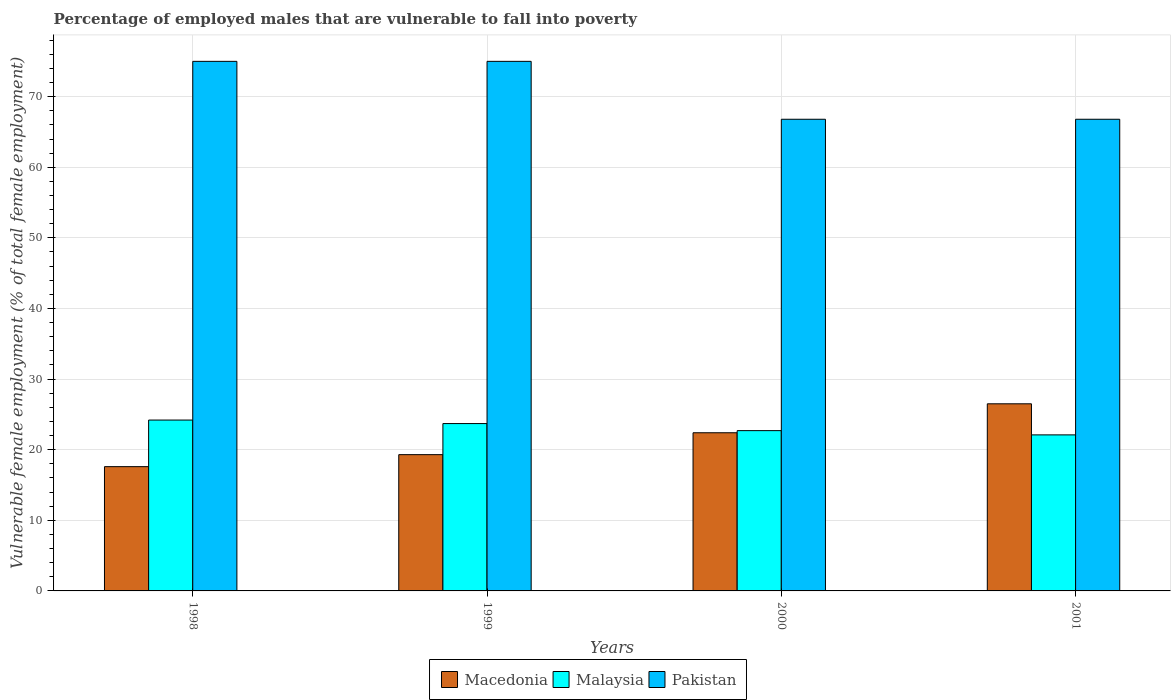What is the label of the 1st group of bars from the left?
Offer a very short reply. 1998. What is the percentage of employed males who are vulnerable to fall into poverty in Macedonia in 2000?
Keep it short and to the point. 22.4. Across all years, what is the maximum percentage of employed males who are vulnerable to fall into poverty in Malaysia?
Your answer should be compact. 24.2. Across all years, what is the minimum percentage of employed males who are vulnerable to fall into poverty in Malaysia?
Give a very brief answer. 22.1. In which year was the percentage of employed males who are vulnerable to fall into poverty in Macedonia maximum?
Your response must be concise. 2001. What is the total percentage of employed males who are vulnerable to fall into poverty in Macedonia in the graph?
Ensure brevity in your answer.  85.8. What is the difference between the percentage of employed males who are vulnerable to fall into poverty in Malaysia in 1998 and that in 2000?
Offer a terse response. 1.5. What is the difference between the percentage of employed males who are vulnerable to fall into poverty in Macedonia in 2000 and the percentage of employed males who are vulnerable to fall into poverty in Malaysia in 1998?
Your answer should be compact. -1.8. What is the average percentage of employed males who are vulnerable to fall into poverty in Macedonia per year?
Offer a terse response. 21.45. In the year 2000, what is the difference between the percentage of employed males who are vulnerable to fall into poverty in Malaysia and percentage of employed males who are vulnerable to fall into poverty in Macedonia?
Your response must be concise. 0.3. In how many years, is the percentage of employed males who are vulnerable to fall into poverty in Malaysia greater than 74 %?
Ensure brevity in your answer.  0. What is the ratio of the percentage of employed males who are vulnerable to fall into poverty in Macedonia in 1998 to that in 1999?
Keep it short and to the point. 0.91. What is the difference between the highest and the lowest percentage of employed males who are vulnerable to fall into poverty in Pakistan?
Your answer should be compact. 8.2. In how many years, is the percentage of employed males who are vulnerable to fall into poverty in Pakistan greater than the average percentage of employed males who are vulnerable to fall into poverty in Pakistan taken over all years?
Your answer should be compact. 2. Is the sum of the percentage of employed males who are vulnerable to fall into poverty in Macedonia in 1999 and 2000 greater than the maximum percentage of employed males who are vulnerable to fall into poverty in Pakistan across all years?
Provide a succinct answer. No. What does the 1st bar from the left in 1998 represents?
Your response must be concise. Macedonia. What does the 3rd bar from the right in 2000 represents?
Give a very brief answer. Macedonia. How many years are there in the graph?
Make the answer very short. 4. Are the values on the major ticks of Y-axis written in scientific E-notation?
Your response must be concise. No. Where does the legend appear in the graph?
Offer a terse response. Bottom center. How many legend labels are there?
Provide a succinct answer. 3. What is the title of the graph?
Your answer should be compact. Percentage of employed males that are vulnerable to fall into poverty. What is the label or title of the Y-axis?
Provide a short and direct response. Vulnerable female employment (% of total female employment). What is the Vulnerable female employment (% of total female employment) in Macedonia in 1998?
Offer a terse response. 17.6. What is the Vulnerable female employment (% of total female employment) in Malaysia in 1998?
Give a very brief answer. 24.2. What is the Vulnerable female employment (% of total female employment) in Macedonia in 1999?
Your answer should be very brief. 19.3. What is the Vulnerable female employment (% of total female employment) in Malaysia in 1999?
Ensure brevity in your answer.  23.7. What is the Vulnerable female employment (% of total female employment) in Pakistan in 1999?
Your response must be concise. 75. What is the Vulnerable female employment (% of total female employment) of Macedonia in 2000?
Give a very brief answer. 22.4. What is the Vulnerable female employment (% of total female employment) of Malaysia in 2000?
Offer a very short reply. 22.7. What is the Vulnerable female employment (% of total female employment) of Pakistan in 2000?
Offer a terse response. 66.8. What is the Vulnerable female employment (% of total female employment) in Macedonia in 2001?
Your answer should be very brief. 26.5. What is the Vulnerable female employment (% of total female employment) of Malaysia in 2001?
Provide a succinct answer. 22.1. What is the Vulnerable female employment (% of total female employment) of Pakistan in 2001?
Your answer should be compact. 66.8. Across all years, what is the maximum Vulnerable female employment (% of total female employment) in Macedonia?
Offer a very short reply. 26.5. Across all years, what is the maximum Vulnerable female employment (% of total female employment) in Malaysia?
Your answer should be very brief. 24.2. Across all years, what is the minimum Vulnerable female employment (% of total female employment) of Macedonia?
Keep it short and to the point. 17.6. Across all years, what is the minimum Vulnerable female employment (% of total female employment) in Malaysia?
Give a very brief answer. 22.1. Across all years, what is the minimum Vulnerable female employment (% of total female employment) of Pakistan?
Your answer should be very brief. 66.8. What is the total Vulnerable female employment (% of total female employment) of Macedonia in the graph?
Provide a short and direct response. 85.8. What is the total Vulnerable female employment (% of total female employment) in Malaysia in the graph?
Keep it short and to the point. 92.7. What is the total Vulnerable female employment (% of total female employment) in Pakistan in the graph?
Provide a succinct answer. 283.6. What is the difference between the Vulnerable female employment (% of total female employment) in Malaysia in 1998 and that in 2000?
Provide a short and direct response. 1.5. What is the difference between the Vulnerable female employment (% of total female employment) in Macedonia in 1998 and that in 2001?
Provide a short and direct response. -8.9. What is the difference between the Vulnerable female employment (% of total female employment) of Malaysia in 1998 and that in 2001?
Your answer should be compact. 2.1. What is the difference between the Vulnerable female employment (% of total female employment) in Pakistan in 1998 and that in 2001?
Offer a very short reply. 8.2. What is the difference between the Vulnerable female employment (% of total female employment) of Macedonia in 1999 and that in 2000?
Give a very brief answer. -3.1. What is the difference between the Vulnerable female employment (% of total female employment) of Pakistan in 1999 and that in 2000?
Give a very brief answer. 8.2. What is the difference between the Vulnerable female employment (% of total female employment) in Macedonia in 1999 and that in 2001?
Make the answer very short. -7.2. What is the difference between the Vulnerable female employment (% of total female employment) in Macedonia in 1998 and the Vulnerable female employment (% of total female employment) in Pakistan in 1999?
Your answer should be very brief. -57.4. What is the difference between the Vulnerable female employment (% of total female employment) in Malaysia in 1998 and the Vulnerable female employment (% of total female employment) in Pakistan in 1999?
Your response must be concise. -50.8. What is the difference between the Vulnerable female employment (% of total female employment) of Macedonia in 1998 and the Vulnerable female employment (% of total female employment) of Malaysia in 2000?
Offer a very short reply. -5.1. What is the difference between the Vulnerable female employment (% of total female employment) in Macedonia in 1998 and the Vulnerable female employment (% of total female employment) in Pakistan in 2000?
Your response must be concise. -49.2. What is the difference between the Vulnerable female employment (% of total female employment) in Malaysia in 1998 and the Vulnerable female employment (% of total female employment) in Pakistan in 2000?
Give a very brief answer. -42.6. What is the difference between the Vulnerable female employment (% of total female employment) in Macedonia in 1998 and the Vulnerable female employment (% of total female employment) in Malaysia in 2001?
Give a very brief answer. -4.5. What is the difference between the Vulnerable female employment (% of total female employment) of Macedonia in 1998 and the Vulnerable female employment (% of total female employment) of Pakistan in 2001?
Provide a succinct answer. -49.2. What is the difference between the Vulnerable female employment (% of total female employment) in Malaysia in 1998 and the Vulnerable female employment (% of total female employment) in Pakistan in 2001?
Offer a terse response. -42.6. What is the difference between the Vulnerable female employment (% of total female employment) of Macedonia in 1999 and the Vulnerable female employment (% of total female employment) of Malaysia in 2000?
Your answer should be compact. -3.4. What is the difference between the Vulnerable female employment (% of total female employment) of Macedonia in 1999 and the Vulnerable female employment (% of total female employment) of Pakistan in 2000?
Provide a short and direct response. -47.5. What is the difference between the Vulnerable female employment (% of total female employment) in Malaysia in 1999 and the Vulnerable female employment (% of total female employment) in Pakistan in 2000?
Your response must be concise. -43.1. What is the difference between the Vulnerable female employment (% of total female employment) of Macedonia in 1999 and the Vulnerable female employment (% of total female employment) of Malaysia in 2001?
Offer a terse response. -2.8. What is the difference between the Vulnerable female employment (% of total female employment) in Macedonia in 1999 and the Vulnerable female employment (% of total female employment) in Pakistan in 2001?
Give a very brief answer. -47.5. What is the difference between the Vulnerable female employment (% of total female employment) of Malaysia in 1999 and the Vulnerable female employment (% of total female employment) of Pakistan in 2001?
Make the answer very short. -43.1. What is the difference between the Vulnerable female employment (% of total female employment) of Macedonia in 2000 and the Vulnerable female employment (% of total female employment) of Malaysia in 2001?
Provide a short and direct response. 0.3. What is the difference between the Vulnerable female employment (% of total female employment) of Macedonia in 2000 and the Vulnerable female employment (% of total female employment) of Pakistan in 2001?
Offer a very short reply. -44.4. What is the difference between the Vulnerable female employment (% of total female employment) of Malaysia in 2000 and the Vulnerable female employment (% of total female employment) of Pakistan in 2001?
Your response must be concise. -44.1. What is the average Vulnerable female employment (% of total female employment) of Macedonia per year?
Make the answer very short. 21.45. What is the average Vulnerable female employment (% of total female employment) in Malaysia per year?
Provide a short and direct response. 23.18. What is the average Vulnerable female employment (% of total female employment) of Pakistan per year?
Keep it short and to the point. 70.9. In the year 1998, what is the difference between the Vulnerable female employment (% of total female employment) of Macedonia and Vulnerable female employment (% of total female employment) of Malaysia?
Your response must be concise. -6.6. In the year 1998, what is the difference between the Vulnerable female employment (% of total female employment) of Macedonia and Vulnerable female employment (% of total female employment) of Pakistan?
Give a very brief answer. -57.4. In the year 1998, what is the difference between the Vulnerable female employment (% of total female employment) in Malaysia and Vulnerable female employment (% of total female employment) in Pakistan?
Offer a terse response. -50.8. In the year 1999, what is the difference between the Vulnerable female employment (% of total female employment) in Macedonia and Vulnerable female employment (% of total female employment) in Malaysia?
Your response must be concise. -4.4. In the year 1999, what is the difference between the Vulnerable female employment (% of total female employment) in Macedonia and Vulnerable female employment (% of total female employment) in Pakistan?
Your answer should be compact. -55.7. In the year 1999, what is the difference between the Vulnerable female employment (% of total female employment) in Malaysia and Vulnerable female employment (% of total female employment) in Pakistan?
Your response must be concise. -51.3. In the year 2000, what is the difference between the Vulnerable female employment (% of total female employment) of Macedonia and Vulnerable female employment (% of total female employment) of Pakistan?
Offer a terse response. -44.4. In the year 2000, what is the difference between the Vulnerable female employment (% of total female employment) of Malaysia and Vulnerable female employment (% of total female employment) of Pakistan?
Your answer should be very brief. -44.1. In the year 2001, what is the difference between the Vulnerable female employment (% of total female employment) in Macedonia and Vulnerable female employment (% of total female employment) in Malaysia?
Your answer should be compact. 4.4. In the year 2001, what is the difference between the Vulnerable female employment (% of total female employment) of Macedonia and Vulnerable female employment (% of total female employment) of Pakistan?
Offer a terse response. -40.3. In the year 2001, what is the difference between the Vulnerable female employment (% of total female employment) of Malaysia and Vulnerable female employment (% of total female employment) of Pakistan?
Keep it short and to the point. -44.7. What is the ratio of the Vulnerable female employment (% of total female employment) of Macedonia in 1998 to that in 1999?
Your response must be concise. 0.91. What is the ratio of the Vulnerable female employment (% of total female employment) in Malaysia in 1998 to that in 1999?
Give a very brief answer. 1.02. What is the ratio of the Vulnerable female employment (% of total female employment) in Macedonia in 1998 to that in 2000?
Your response must be concise. 0.79. What is the ratio of the Vulnerable female employment (% of total female employment) of Malaysia in 1998 to that in 2000?
Your answer should be compact. 1.07. What is the ratio of the Vulnerable female employment (% of total female employment) of Pakistan in 1998 to that in 2000?
Keep it short and to the point. 1.12. What is the ratio of the Vulnerable female employment (% of total female employment) in Macedonia in 1998 to that in 2001?
Provide a short and direct response. 0.66. What is the ratio of the Vulnerable female employment (% of total female employment) of Malaysia in 1998 to that in 2001?
Ensure brevity in your answer.  1.09. What is the ratio of the Vulnerable female employment (% of total female employment) in Pakistan in 1998 to that in 2001?
Make the answer very short. 1.12. What is the ratio of the Vulnerable female employment (% of total female employment) of Macedonia in 1999 to that in 2000?
Provide a succinct answer. 0.86. What is the ratio of the Vulnerable female employment (% of total female employment) of Malaysia in 1999 to that in 2000?
Your answer should be very brief. 1.04. What is the ratio of the Vulnerable female employment (% of total female employment) of Pakistan in 1999 to that in 2000?
Your answer should be compact. 1.12. What is the ratio of the Vulnerable female employment (% of total female employment) in Macedonia in 1999 to that in 2001?
Give a very brief answer. 0.73. What is the ratio of the Vulnerable female employment (% of total female employment) of Malaysia in 1999 to that in 2001?
Keep it short and to the point. 1.07. What is the ratio of the Vulnerable female employment (% of total female employment) in Pakistan in 1999 to that in 2001?
Your answer should be compact. 1.12. What is the ratio of the Vulnerable female employment (% of total female employment) of Macedonia in 2000 to that in 2001?
Your answer should be very brief. 0.85. What is the ratio of the Vulnerable female employment (% of total female employment) in Malaysia in 2000 to that in 2001?
Give a very brief answer. 1.03. What is the difference between the highest and the second highest Vulnerable female employment (% of total female employment) of Macedonia?
Offer a terse response. 4.1. What is the difference between the highest and the second highest Vulnerable female employment (% of total female employment) in Pakistan?
Make the answer very short. 0. What is the difference between the highest and the lowest Vulnerable female employment (% of total female employment) in Macedonia?
Provide a succinct answer. 8.9. What is the difference between the highest and the lowest Vulnerable female employment (% of total female employment) in Pakistan?
Your answer should be compact. 8.2. 